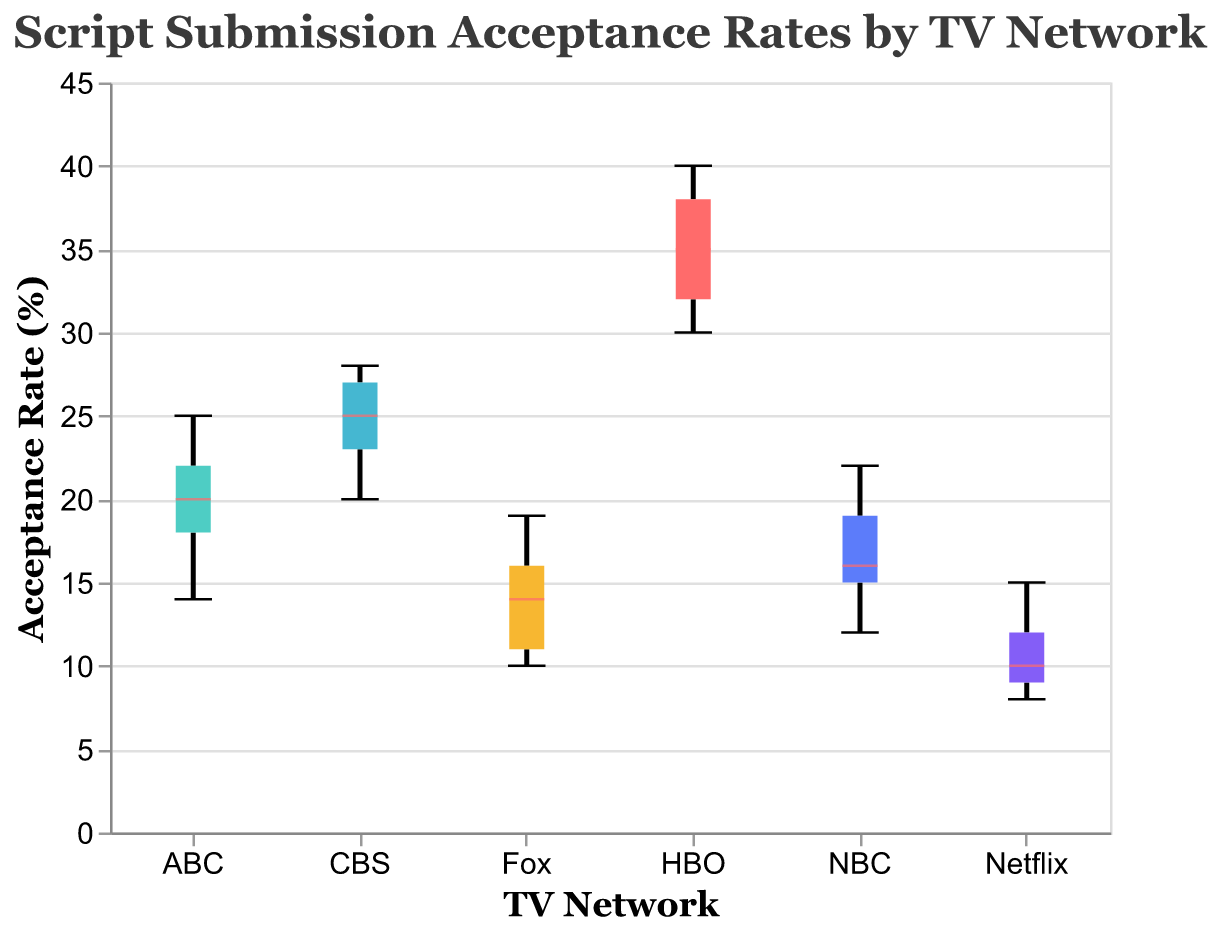How many networks are represented in the box plot? To determine the number of networks, count the distinct groups on the x-axis. The networks indicated are ABC, NBC, CBS, Fox, HBO, and Netflix.
Answer: 6 What's the title of the box plot? Look at the text displayed at the top of the figure. The title is usually prominently displayed there. In this case, the title is "Script Submission Acceptance Rates by TV Network".
Answer: Script Submission Acceptance Rates by TV Network Which network has the lowest median acceptance rate? To find the network with the lowest median acceptance rate, look for the median line (usually indicated by a different color) within the box plot for each network. Find the network where this line is lowest. Netflix has the lowest median acceptance rate.
Answer: Netflix What is the range of acceptance rates for HBO? To determine the range of acceptance rates for HBO, look at the distance between the top and bottom whiskers of the box plot for HBO. The minimum rate is 30% and the maximum rate is 40%. Therefore, the range is 40% - 30% = 10%.
Answer: 10% Which network has the widest spread of acceptance rates? To find the network with the widest spread, compare the lengths of the boxes and whiskers for each network. HBO has the widest spread (10%), while ABC, NBC, CBS, Fox, Netflix all have smaller spreads.
Answer: HBO Compare the median acceptance rate of CBS with Netflix. Which one is higher? Examine the median lines within the boxes for CBS and Netflix. CBS's median is higher than Netflix's median. CBS's median appears to be around 25%, while Netflix's median is below 10%.
Answer: CBS What is the interquartile range (IQR) for ABC? To find the IQR, locate the top and bottom of the box for ABC. The IQR is the difference between these values. For ABC, the values are approximately 14% (25th percentile) and 22% (75th percentile), so the IQR is 22% - 14% = 8%.
Answer: 8% Based on the box plot, which network seems to be the most selective (i.e., lowest acceptance rates overall)? Identify which network has the lowest values on the box plot overall. Netflix consistently has lower acceptance rates compared to other networks as indicated by its entire range.
Answer: Netflix What is the median acceptance rate for HBO? Look for the median line within the box for HBO. It appears to be around 35%.
Answer: 35% How does the variability in acceptance rates compare between Fox and CBS? Compare the range and the IQR of the boxes for Fox and CBS. CBS has higher variability with a larger IQR and wider range between the whiskers, while Fox's range is more condensed and closer together.
Answer: CBS 